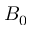Convert formula to latex. <formula><loc_0><loc_0><loc_500><loc_500>B _ { 0 }</formula> 